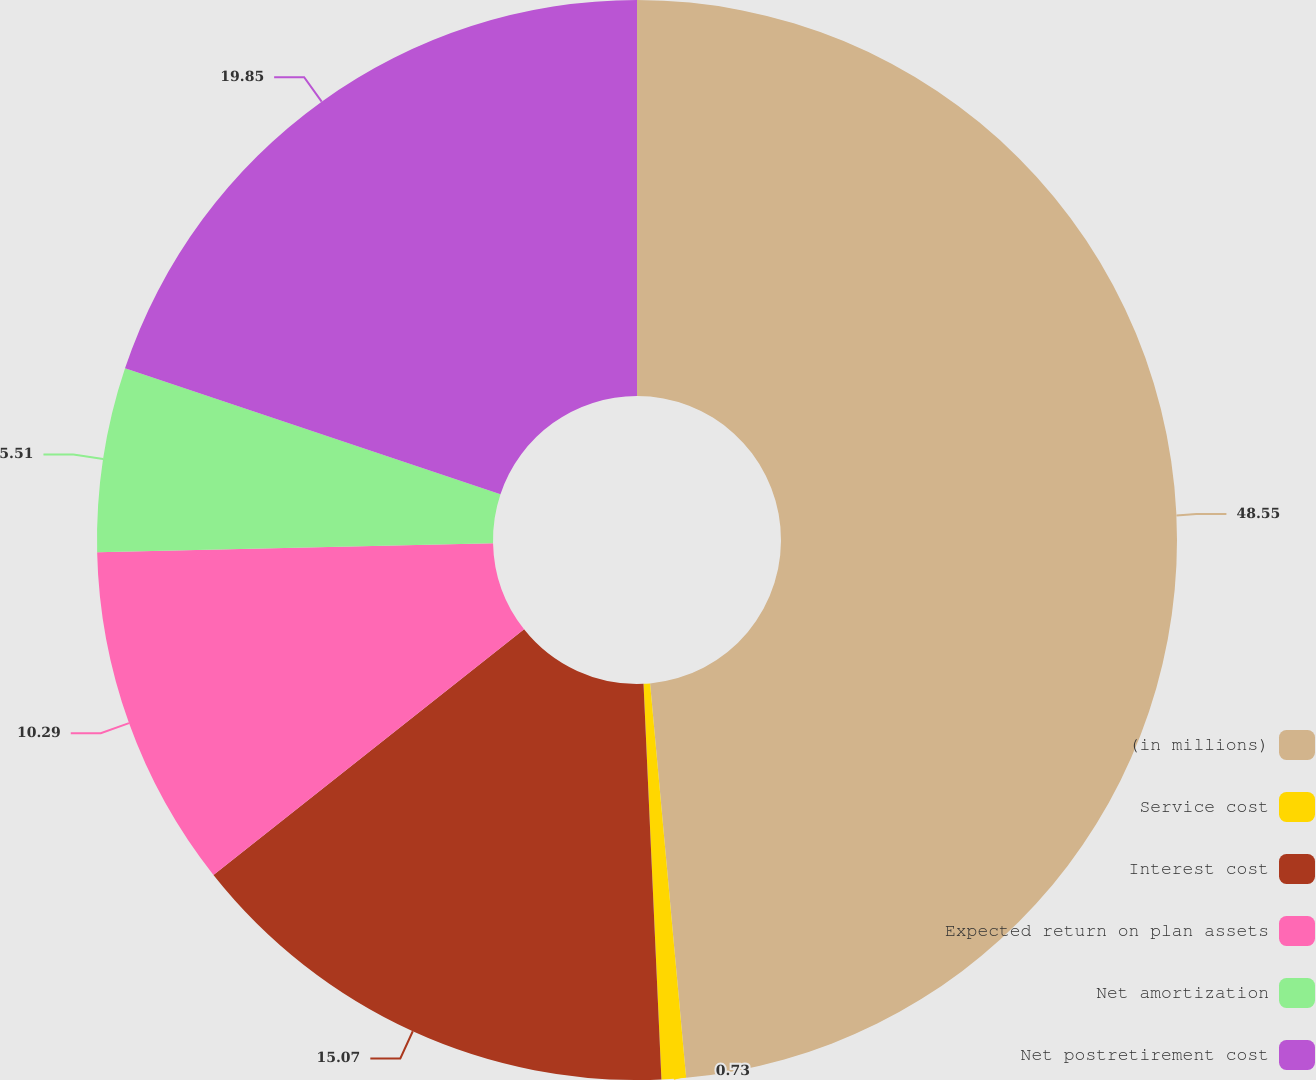Convert chart. <chart><loc_0><loc_0><loc_500><loc_500><pie_chart><fcel>(in millions)<fcel>Service cost<fcel>Interest cost<fcel>Expected return on plan assets<fcel>Net amortization<fcel>Net postretirement cost<nl><fcel>48.55%<fcel>0.73%<fcel>15.07%<fcel>10.29%<fcel>5.51%<fcel>19.85%<nl></chart> 